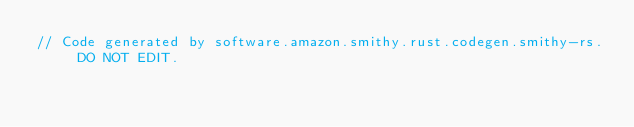<code> <loc_0><loc_0><loc_500><loc_500><_Rust_>// Code generated by software.amazon.smithy.rust.codegen.smithy-rs. DO NOT EDIT.</code> 